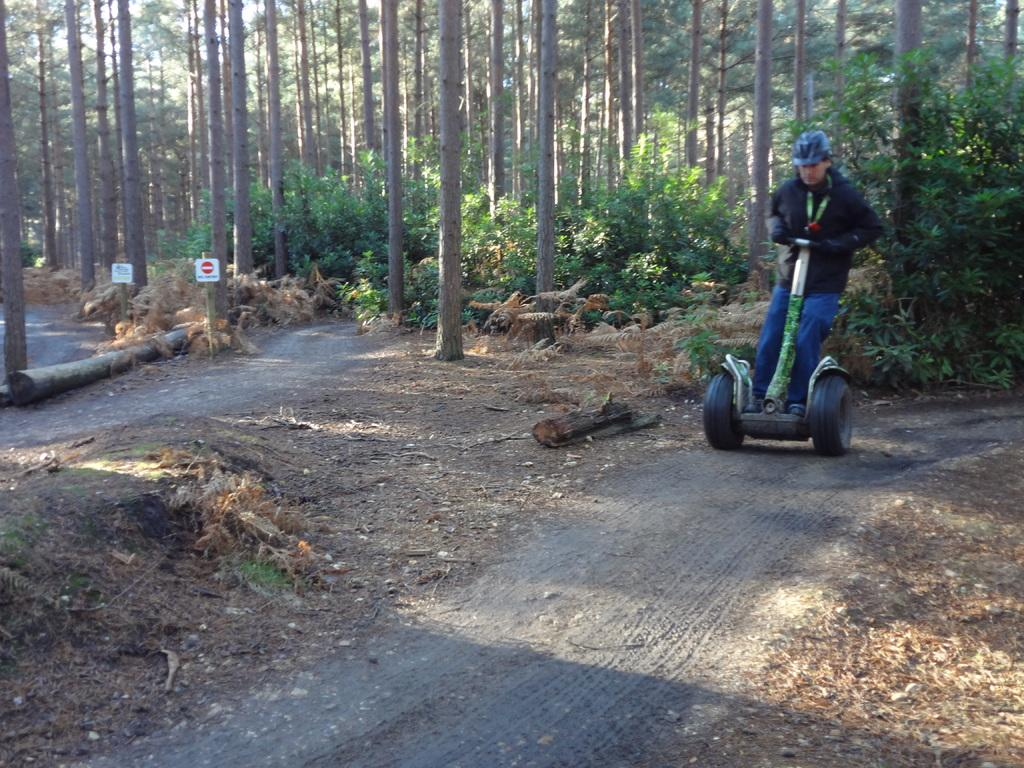What is the main subject of the image? There is a person in the image. What is the person wearing? The person is wearing a black jacket and a helmet. How is the person moving in the image? The person is moving on a cart. What can be seen at the bottom of the image? There is a road visible at the bottom of the image. What is visible in the background of the image? There are trees in the background of the image. Can you tell me how many deer are visible in the image? There are no deer present in the image; it features a person moving on a cart with a road and trees in the background. 